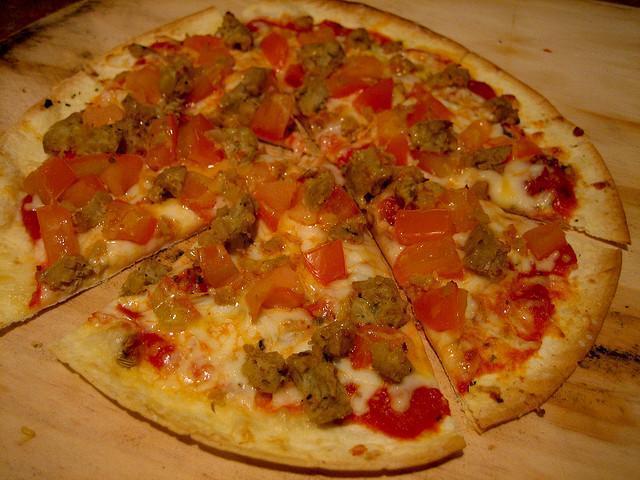How many slices of pizza are there?
Give a very brief answer. 7. How many slices is the pizza divided into?
Give a very brief answer. 6. How many pizzas are in the picture?
Give a very brief answer. 3. 